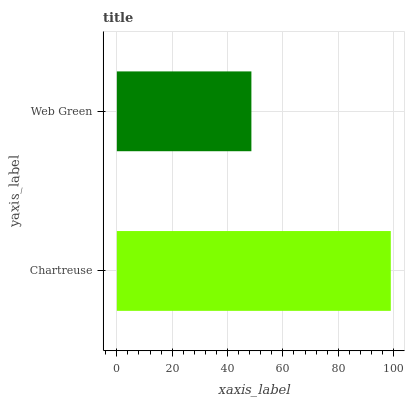Is Web Green the minimum?
Answer yes or no. Yes. Is Chartreuse the maximum?
Answer yes or no. Yes. Is Web Green the maximum?
Answer yes or no. No. Is Chartreuse greater than Web Green?
Answer yes or no. Yes. Is Web Green less than Chartreuse?
Answer yes or no. Yes. Is Web Green greater than Chartreuse?
Answer yes or no. No. Is Chartreuse less than Web Green?
Answer yes or no. No. Is Chartreuse the high median?
Answer yes or no. Yes. Is Web Green the low median?
Answer yes or no. Yes. Is Web Green the high median?
Answer yes or no. No. Is Chartreuse the low median?
Answer yes or no. No. 